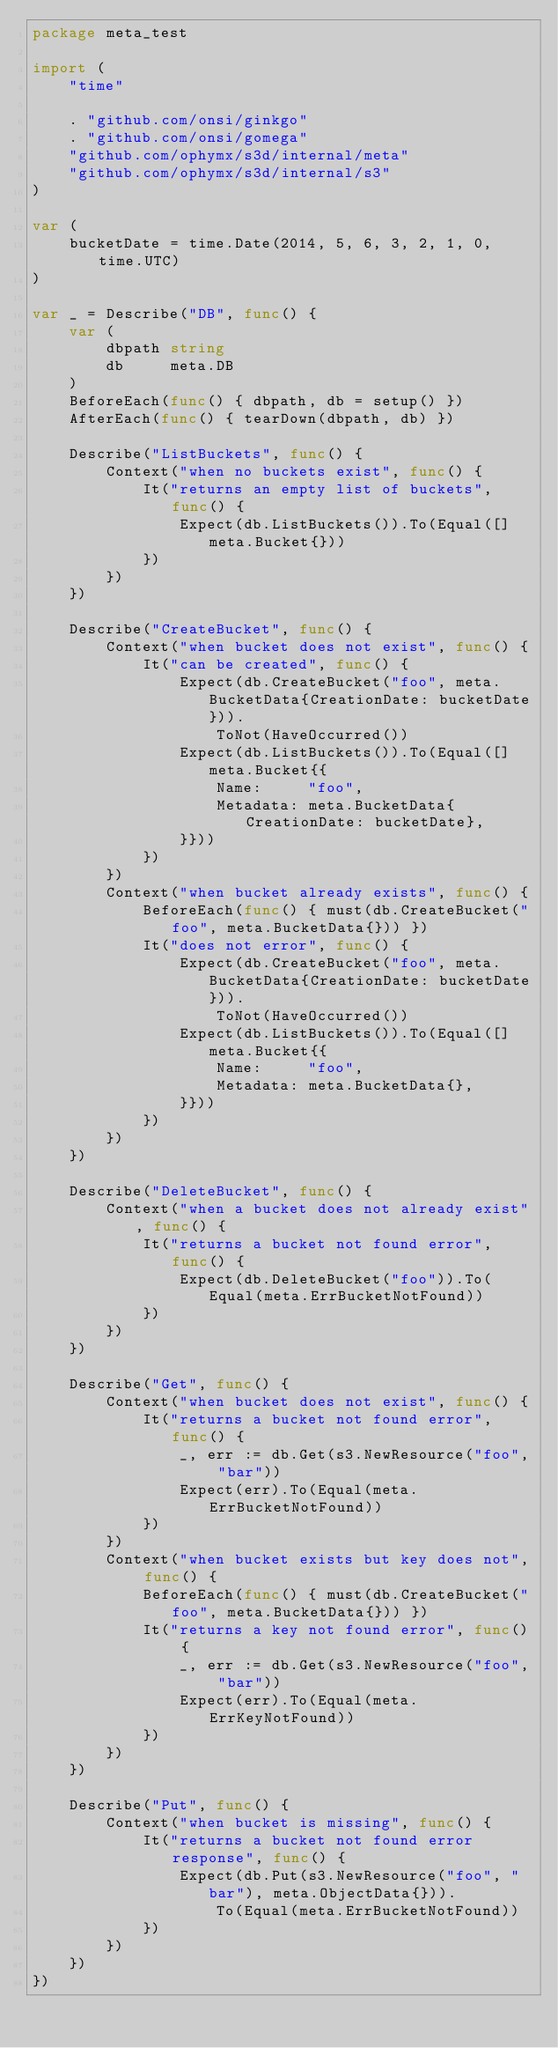<code> <loc_0><loc_0><loc_500><loc_500><_Go_>package meta_test

import (
	"time"

	. "github.com/onsi/ginkgo"
	. "github.com/onsi/gomega"
	"github.com/ophymx/s3d/internal/meta"
	"github.com/ophymx/s3d/internal/s3"
)

var (
	bucketDate = time.Date(2014, 5, 6, 3, 2, 1, 0, time.UTC)
)

var _ = Describe("DB", func() {
	var (
		dbpath string
		db     meta.DB
	)
	BeforeEach(func() { dbpath, db = setup() })
	AfterEach(func() { tearDown(dbpath, db) })

	Describe("ListBuckets", func() {
		Context("when no buckets exist", func() {
			It("returns an empty list of buckets", func() {
				Expect(db.ListBuckets()).To(Equal([]meta.Bucket{}))
			})
		})
	})

	Describe("CreateBucket", func() {
		Context("when bucket does not exist", func() {
			It("can be created", func() {
				Expect(db.CreateBucket("foo", meta.BucketData{CreationDate: bucketDate})).
					ToNot(HaveOccurred())
				Expect(db.ListBuckets()).To(Equal([]meta.Bucket{{
					Name:     "foo",
					Metadata: meta.BucketData{CreationDate: bucketDate},
				}}))
			})
		})
		Context("when bucket already exists", func() {
			BeforeEach(func() { must(db.CreateBucket("foo", meta.BucketData{})) })
			It("does not error", func() {
				Expect(db.CreateBucket("foo", meta.BucketData{CreationDate: bucketDate})).
					ToNot(HaveOccurred())
				Expect(db.ListBuckets()).To(Equal([]meta.Bucket{{
					Name:     "foo",
					Metadata: meta.BucketData{},
				}}))
			})
		})
	})

	Describe("DeleteBucket", func() {
		Context("when a bucket does not already exist", func() {
			It("returns a bucket not found error", func() {
				Expect(db.DeleteBucket("foo")).To(Equal(meta.ErrBucketNotFound))
			})
		})
	})

	Describe("Get", func() {
		Context("when bucket does not exist", func() {
			It("returns a bucket not found error", func() {
				_, err := db.Get(s3.NewResource("foo", "bar"))
				Expect(err).To(Equal(meta.ErrBucketNotFound))
			})
		})
		Context("when bucket exists but key does not", func() {
			BeforeEach(func() { must(db.CreateBucket("foo", meta.BucketData{})) })
			It("returns a key not found error", func() {
				_, err := db.Get(s3.NewResource("foo", "bar"))
				Expect(err).To(Equal(meta.ErrKeyNotFound))
			})
		})
	})

	Describe("Put", func() {
		Context("when bucket is missing", func() {
			It("returns a bucket not found error response", func() {
				Expect(db.Put(s3.NewResource("foo", "bar"), meta.ObjectData{})).
					To(Equal(meta.ErrBucketNotFound))
			})
		})
	})
})
</code> 